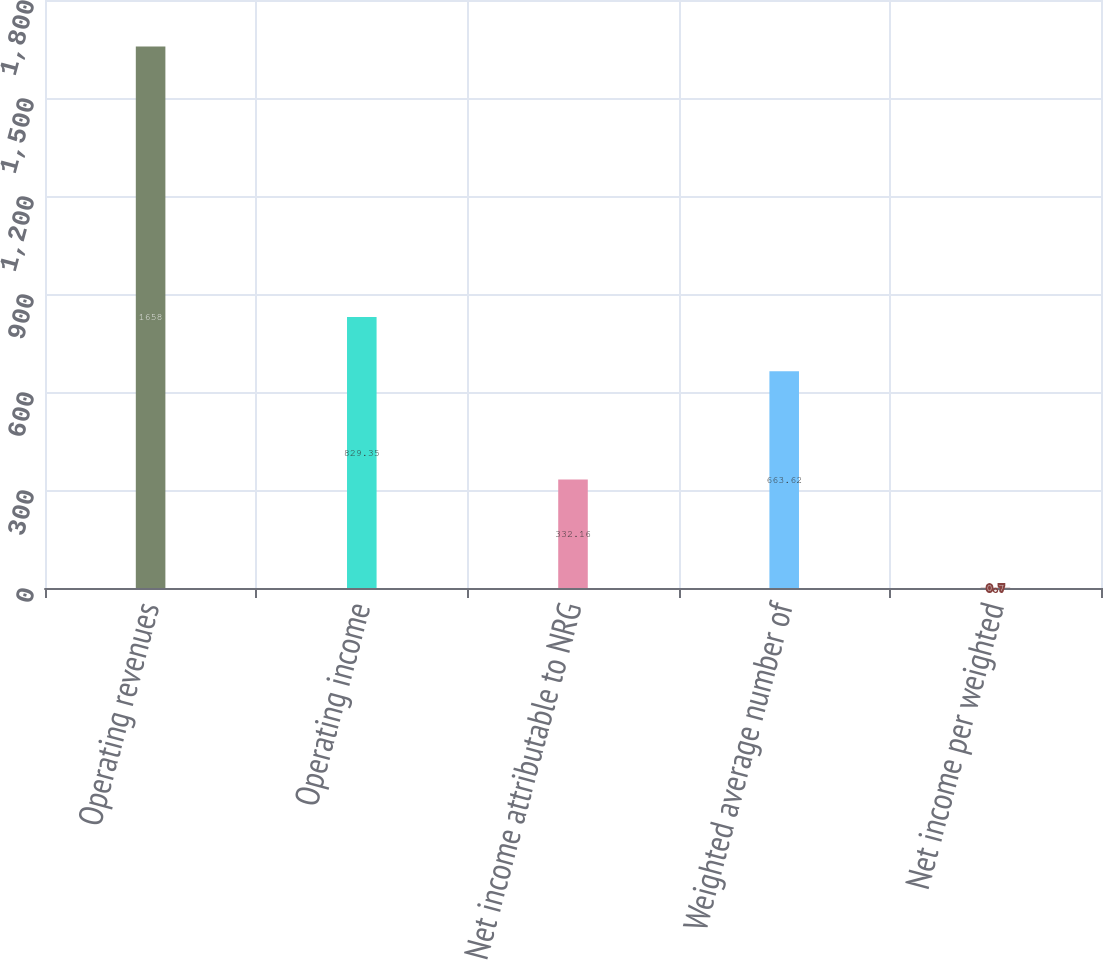Convert chart. <chart><loc_0><loc_0><loc_500><loc_500><bar_chart><fcel>Operating revenues<fcel>Operating income<fcel>Net income attributable to NRG<fcel>Weighted average number of<fcel>Net income per weighted<nl><fcel>1658<fcel>829.35<fcel>332.16<fcel>663.62<fcel>0.7<nl></chart> 